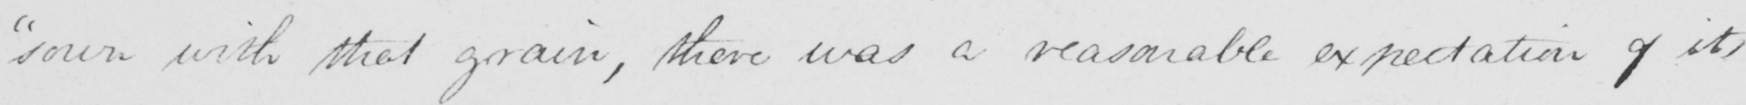Can you tell me what this handwritten text says? sown with that grain , there was a reasonable expectation of its 